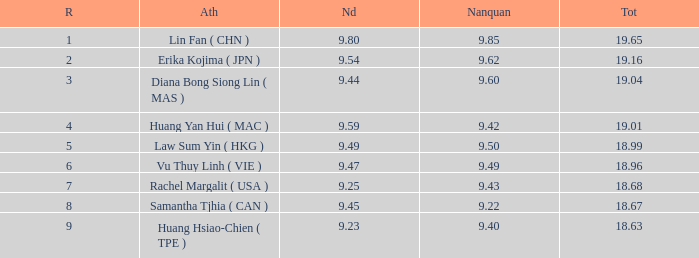Which Nanquan has a Nandao smaller than 9.44, and a Rank smaller than 9, and a Total larger than 18.68? None. 